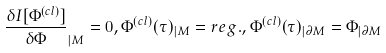Convert formula to latex. <formula><loc_0><loc_0><loc_500><loc_500>\frac { { \delta } I [ \Phi ^ { ( c l ) } ] } { { \delta } { \Phi } } _ { | M } = 0 , \Phi ^ { ( c l ) } ( \tau ) _ { | M } = r e g . , \Phi ^ { ( c l ) } ( \tau ) _ { | { \partial } M } = \Phi _ { | { \partial } M }</formula> 